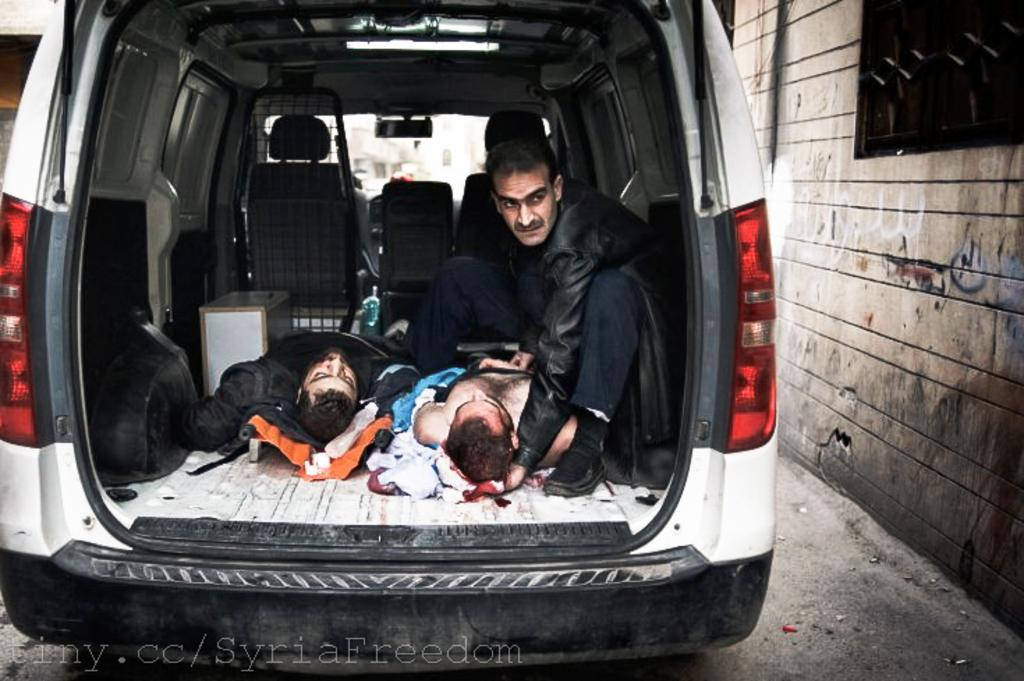How many people are inside the car in the image? There are two persons lying inside the car and one person sitting inside the car. What is the position of the people inside the car? Two persons are lying inside the car, and one person is sitting inside the car. What can be seen in the background of the image? There is a wall visible in the image. What type of acoustics can be heard inside the car in the image? There is no information about the acoustics inside the car in the image. How does the heat affect the people inside the car in the image? There is no information about the temperature or heat inside the car in the image. 